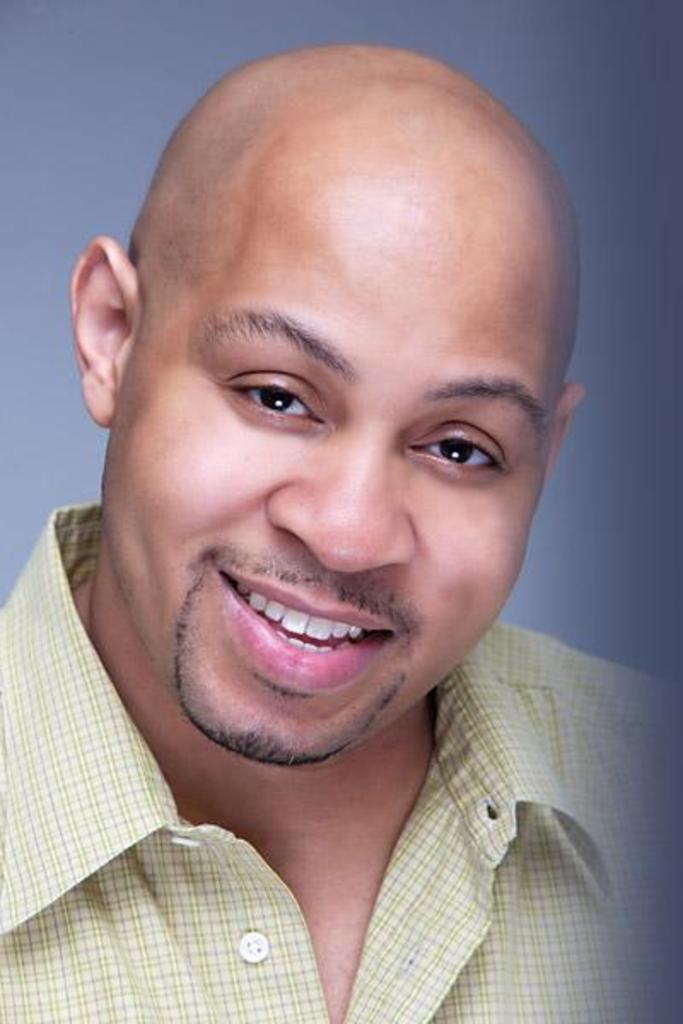Who is present in the image? There is a man in the image. What is the man wearing? The man is wearing a shirt. What color is the background of the image? The background of the image is light grey in color. How many beans are visible in the image? There are no beans present in the image. What type of support is the man using in the image? The image does not show the man using any support. 